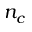Convert formula to latex. <formula><loc_0><loc_0><loc_500><loc_500>n _ { c }</formula> 